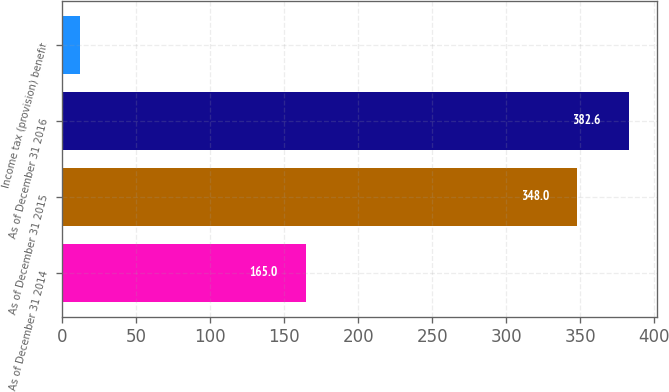<chart> <loc_0><loc_0><loc_500><loc_500><bar_chart><fcel>As of December 31 2014<fcel>As of December 31 2015<fcel>As of December 31 2016<fcel>Income tax (provision) benefit<nl><fcel>165<fcel>348<fcel>382.6<fcel>12<nl></chart> 